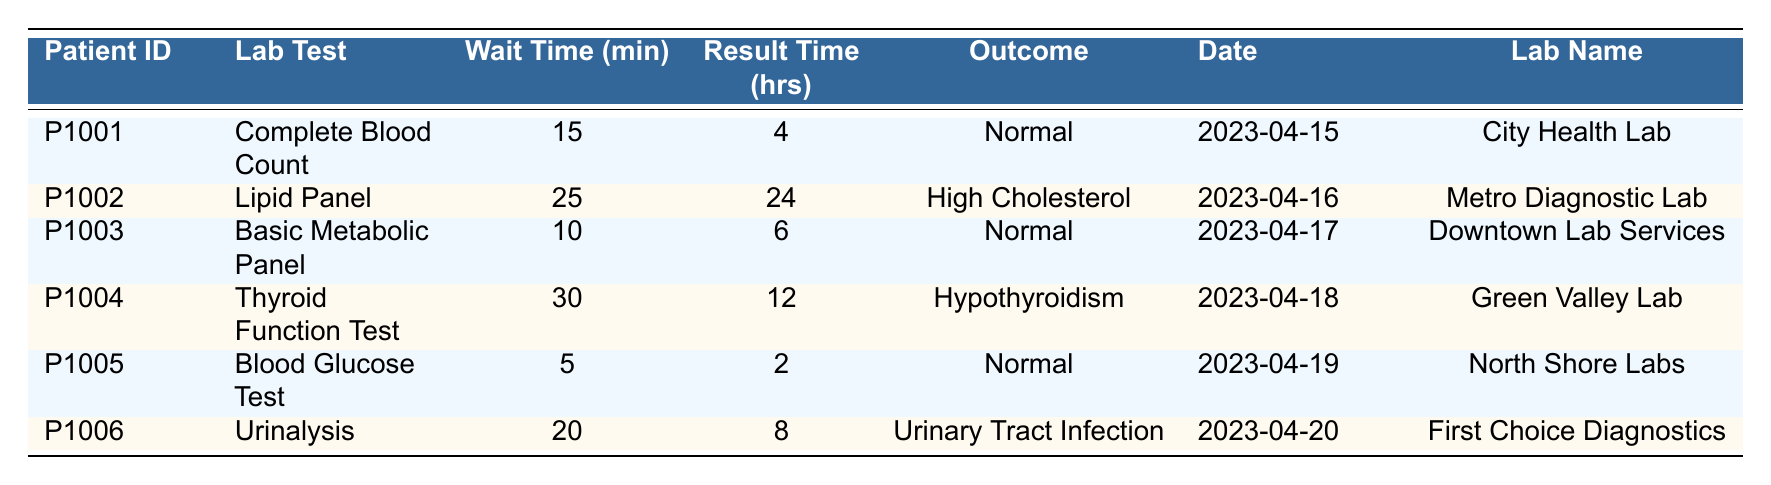What is the maximum wait time recorded in the table? Looking at the "Wait Time (min)" column, the values are 15, 25, 10, 30, 5, and 20. The maximum value among these is 30 minutes, recorded for the Thyroid Function Test.
Answer: 30 What is the average result time for all lab tests? The result times are 4, 24, 6, 12, 2, and 8 hours. Summing these gives 4 + 24 + 6 + 12 + 2 + 8 = 56 hours. There are 6 tests, so the average is 56/6 = 9.33 hours.
Answer: 9.33 Which test had the shortest wait time? Reviewing the "Wait Time (min)" values, the shortest is 5 minutes, associated with the Blood Glucose Test.
Answer: Blood Glucose Test Did any patient wait more than 20 minutes for their lab results? In the "Wait Time (min)" column, the wait times are 15, 25, 10, 30, 5, and 20 minutes. The wait times of 25 and 30 minutes are greater than 20 minutes.
Answer: Yes What percentage of tests resulted in a normal outcome? There are a total of 6 tests, with 4 outcomes classified as "Normal." To find the percentage, divide 4 by 6 and multiply by 100, which gives (4/6) * 100 = 66.67%.
Answer: 66.67% Which lab had the fastest result time? The result times are 4, 24, 6, 12, 2, and 8 hours. The fastest result time is 2 hours for the Blood Glucose Test from North Shore Labs.
Answer: North Shore Labs How many tests were conducted on the same date? The dates of the tests are April 15, 16, 17, 18, 19, and 20. Each date contains one test, making the total count 6.
Answer: 1 per date; total 6 What is the outcome for the patient with ID P1004? Referring to the outcome for Patient ID P1004 in the "Outcome" column, it shows "Hypothyroidism."
Answer: Hypothyroidism 